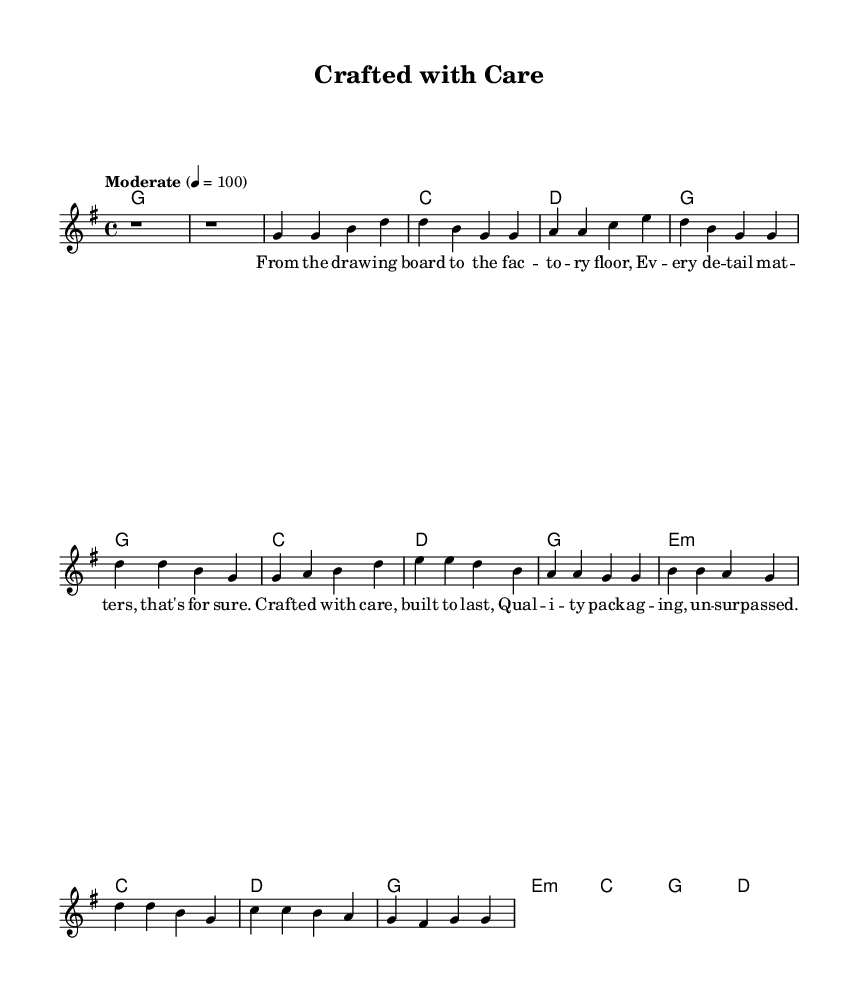What is the key signature of this music? The key signature is G major, which has one sharp (F#). This is determined by examining the signature present at the beginning of the staff.
Answer: G major What is the time signature of this music? The time signature is 4/4, indicated by the numbers at the beginning of the staff. This means there are four beats per measure, and the quarter note receives one beat.
Answer: 4/4 What is the tempo marking of the piece? The tempo marking is "Moderate 4 = 100", which indicates the piece should be played at a moderate speed with a metronome marking of 100 beats per minute. This is often found at the beginning of the score.
Answer: Moderate 4 = 100 How many measures are in the chorus section? The chorus section consists of four measures. By counting the measures in the chorus as indicated by the notation, we can determine this.
Answer: 4 What type of song structure does this piece use? This piece uses a verse-chorus structure, which is typical in country music. The song has an identifiable verse followed by a repeating chorus. Reading the arrangement helps identify this pattern.
Answer: Verse-chorus What theme is being expressed in the lyrics? The theme expressed in the lyrics is craftsmanship and quality. The lyrics emphasize the importance of attention to detail and the durability of the products, common in songs that praise craftsmanship. This can be inferred from the text within the lyrics section.
Answer: Craftsmanship and quality What is the primary instrument indicated in the score? The primary instrument indicated in the score is a lead voice, which is specified in the staff name and context. This implies that the melody is meant to be sung or played as the main feature of the piece.
Answer: Lead voice 